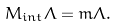Convert formula to latex. <formula><loc_0><loc_0><loc_500><loc_500>M _ { i n t } \Lambda = m \Lambda .</formula> 